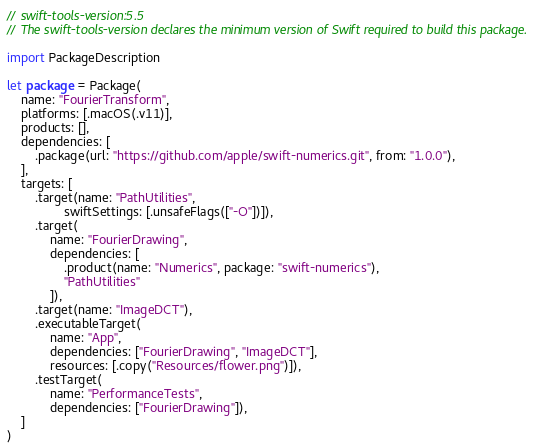Convert code to text. <code><loc_0><loc_0><loc_500><loc_500><_Swift_>// swift-tools-version:5.5
// The swift-tools-version declares the minimum version of Swift required to build this package.

import PackageDescription

let package = Package(
    name: "FourierTransform",
    platforms: [.macOS(.v11)],
    products: [],
    dependencies: [
        .package(url: "https://github.com/apple/swift-numerics.git", from: "1.0.0"),
    ],
    targets: [
        .target(name: "PathUtilities",
                swiftSettings: [.unsafeFlags(["-O"])]),
        .target(
            name: "FourierDrawing",
            dependencies: [
                .product(name: "Numerics", package: "swift-numerics"),
                "PathUtilities"
            ]),
        .target(name: "ImageDCT"),
        .executableTarget(
            name: "App",
            dependencies: ["FourierDrawing", "ImageDCT"],
            resources: [.copy("Resources/flower.png")]),
        .testTarget(
            name: "PerformanceTests",
            dependencies: ["FourierDrawing"]),
    ]
)
</code> 